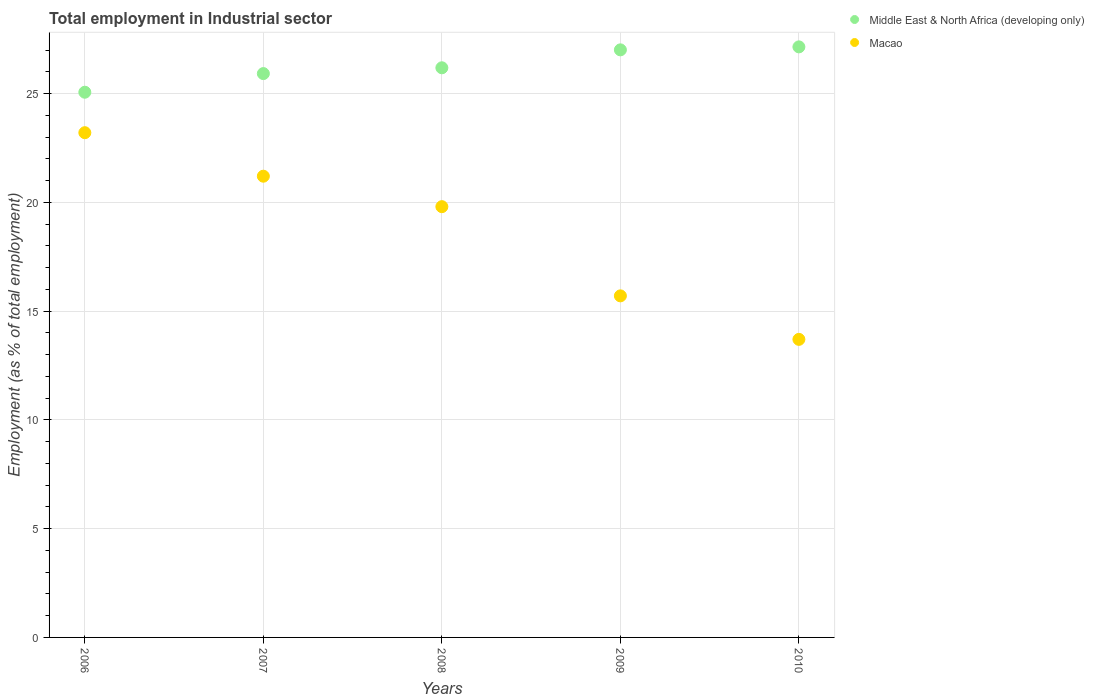How many different coloured dotlines are there?
Make the answer very short. 2. What is the employment in industrial sector in Middle East & North Africa (developing only) in 2009?
Provide a short and direct response. 27.01. Across all years, what is the maximum employment in industrial sector in Macao?
Give a very brief answer. 23.2. Across all years, what is the minimum employment in industrial sector in Macao?
Ensure brevity in your answer.  13.7. In which year was the employment in industrial sector in Middle East & North Africa (developing only) maximum?
Offer a very short reply. 2010. In which year was the employment in industrial sector in Macao minimum?
Ensure brevity in your answer.  2010. What is the total employment in industrial sector in Macao in the graph?
Your response must be concise. 93.6. What is the difference between the employment in industrial sector in Macao in 2006 and that in 2007?
Ensure brevity in your answer.  2. What is the difference between the employment in industrial sector in Middle East & North Africa (developing only) in 2009 and the employment in industrial sector in Macao in 2010?
Give a very brief answer. 13.31. What is the average employment in industrial sector in Middle East & North Africa (developing only) per year?
Your answer should be compact. 26.26. In the year 2009, what is the difference between the employment in industrial sector in Macao and employment in industrial sector in Middle East & North Africa (developing only)?
Give a very brief answer. -11.31. In how many years, is the employment in industrial sector in Middle East & North Africa (developing only) greater than 19 %?
Keep it short and to the point. 5. What is the ratio of the employment in industrial sector in Middle East & North Africa (developing only) in 2006 to that in 2007?
Your answer should be very brief. 0.97. Is the employment in industrial sector in Macao in 2008 less than that in 2010?
Give a very brief answer. No. Is the difference between the employment in industrial sector in Macao in 2007 and 2010 greater than the difference between the employment in industrial sector in Middle East & North Africa (developing only) in 2007 and 2010?
Offer a very short reply. Yes. What is the difference between the highest and the second highest employment in industrial sector in Middle East & North Africa (developing only)?
Your answer should be very brief. 0.14. What is the difference between the highest and the lowest employment in industrial sector in Macao?
Your response must be concise. 9.5. Is the employment in industrial sector in Macao strictly greater than the employment in industrial sector in Middle East & North Africa (developing only) over the years?
Your answer should be very brief. No. Is the employment in industrial sector in Middle East & North Africa (developing only) strictly less than the employment in industrial sector in Macao over the years?
Offer a very short reply. No. How many dotlines are there?
Keep it short and to the point. 2. How many years are there in the graph?
Your response must be concise. 5. Are the values on the major ticks of Y-axis written in scientific E-notation?
Provide a short and direct response. No. How many legend labels are there?
Offer a very short reply. 2. What is the title of the graph?
Your answer should be compact. Total employment in Industrial sector. What is the label or title of the Y-axis?
Make the answer very short. Employment (as % of total employment). What is the Employment (as % of total employment) of Middle East & North Africa (developing only) in 2006?
Provide a short and direct response. 25.06. What is the Employment (as % of total employment) of Macao in 2006?
Your answer should be very brief. 23.2. What is the Employment (as % of total employment) of Middle East & North Africa (developing only) in 2007?
Provide a succinct answer. 25.92. What is the Employment (as % of total employment) in Macao in 2007?
Ensure brevity in your answer.  21.2. What is the Employment (as % of total employment) in Middle East & North Africa (developing only) in 2008?
Give a very brief answer. 26.18. What is the Employment (as % of total employment) of Macao in 2008?
Your answer should be very brief. 19.8. What is the Employment (as % of total employment) in Middle East & North Africa (developing only) in 2009?
Give a very brief answer. 27.01. What is the Employment (as % of total employment) in Macao in 2009?
Offer a very short reply. 15.7. What is the Employment (as % of total employment) of Middle East & North Africa (developing only) in 2010?
Ensure brevity in your answer.  27.14. What is the Employment (as % of total employment) in Macao in 2010?
Your response must be concise. 13.7. Across all years, what is the maximum Employment (as % of total employment) in Middle East & North Africa (developing only)?
Your answer should be compact. 27.14. Across all years, what is the maximum Employment (as % of total employment) in Macao?
Give a very brief answer. 23.2. Across all years, what is the minimum Employment (as % of total employment) in Middle East & North Africa (developing only)?
Your answer should be very brief. 25.06. Across all years, what is the minimum Employment (as % of total employment) of Macao?
Your response must be concise. 13.7. What is the total Employment (as % of total employment) in Middle East & North Africa (developing only) in the graph?
Provide a succinct answer. 131.31. What is the total Employment (as % of total employment) of Macao in the graph?
Your answer should be compact. 93.6. What is the difference between the Employment (as % of total employment) of Middle East & North Africa (developing only) in 2006 and that in 2007?
Offer a very short reply. -0.86. What is the difference between the Employment (as % of total employment) of Macao in 2006 and that in 2007?
Make the answer very short. 2. What is the difference between the Employment (as % of total employment) in Middle East & North Africa (developing only) in 2006 and that in 2008?
Make the answer very short. -1.12. What is the difference between the Employment (as % of total employment) of Macao in 2006 and that in 2008?
Your answer should be very brief. 3.4. What is the difference between the Employment (as % of total employment) in Middle East & North Africa (developing only) in 2006 and that in 2009?
Your answer should be very brief. -1.95. What is the difference between the Employment (as % of total employment) in Macao in 2006 and that in 2009?
Keep it short and to the point. 7.5. What is the difference between the Employment (as % of total employment) of Middle East & North Africa (developing only) in 2006 and that in 2010?
Ensure brevity in your answer.  -2.08. What is the difference between the Employment (as % of total employment) of Middle East & North Africa (developing only) in 2007 and that in 2008?
Provide a succinct answer. -0.27. What is the difference between the Employment (as % of total employment) in Macao in 2007 and that in 2008?
Keep it short and to the point. 1.4. What is the difference between the Employment (as % of total employment) in Middle East & North Africa (developing only) in 2007 and that in 2009?
Make the answer very short. -1.09. What is the difference between the Employment (as % of total employment) of Macao in 2007 and that in 2009?
Give a very brief answer. 5.5. What is the difference between the Employment (as % of total employment) in Middle East & North Africa (developing only) in 2007 and that in 2010?
Your answer should be very brief. -1.23. What is the difference between the Employment (as % of total employment) in Middle East & North Africa (developing only) in 2008 and that in 2009?
Give a very brief answer. -0.82. What is the difference between the Employment (as % of total employment) of Macao in 2008 and that in 2009?
Offer a very short reply. 4.1. What is the difference between the Employment (as % of total employment) in Middle East & North Africa (developing only) in 2008 and that in 2010?
Offer a very short reply. -0.96. What is the difference between the Employment (as % of total employment) in Middle East & North Africa (developing only) in 2009 and that in 2010?
Your response must be concise. -0.14. What is the difference between the Employment (as % of total employment) of Macao in 2009 and that in 2010?
Provide a short and direct response. 2. What is the difference between the Employment (as % of total employment) of Middle East & North Africa (developing only) in 2006 and the Employment (as % of total employment) of Macao in 2007?
Give a very brief answer. 3.86. What is the difference between the Employment (as % of total employment) in Middle East & North Africa (developing only) in 2006 and the Employment (as % of total employment) in Macao in 2008?
Give a very brief answer. 5.26. What is the difference between the Employment (as % of total employment) of Middle East & North Africa (developing only) in 2006 and the Employment (as % of total employment) of Macao in 2009?
Make the answer very short. 9.36. What is the difference between the Employment (as % of total employment) in Middle East & North Africa (developing only) in 2006 and the Employment (as % of total employment) in Macao in 2010?
Offer a terse response. 11.36. What is the difference between the Employment (as % of total employment) in Middle East & North Africa (developing only) in 2007 and the Employment (as % of total employment) in Macao in 2008?
Offer a terse response. 6.12. What is the difference between the Employment (as % of total employment) in Middle East & North Africa (developing only) in 2007 and the Employment (as % of total employment) in Macao in 2009?
Your response must be concise. 10.22. What is the difference between the Employment (as % of total employment) of Middle East & North Africa (developing only) in 2007 and the Employment (as % of total employment) of Macao in 2010?
Give a very brief answer. 12.22. What is the difference between the Employment (as % of total employment) in Middle East & North Africa (developing only) in 2008 and the Employment (as % of total employment) in Macao in 2009?
Provide a short and direct response. 10.48. What is the difference between the Employment (as % of total employment) of Middle East & North Africa (developing only) in 2008 and the Employment (as % of total employment) of Macao in 2010?
Your answer should be compact. 12.48. What is the difference between the Employment (as % of total employment) in Middle East & North Africa (developing only) in 2009 and the Employment (as % of total employment) in Macao in 2010?
Offer a very short reply. 13.31. What is the average Employment (as % of total employment) of Middle East & North Africa (developing only) per year?
Provide a succinct answer. 26.26. What is the average Employment (as % of total employment) in Macao per year?
Your response must be concise. 18.72. In the year 2006, what is the difference between the Employment (as % of total employment) in Middle East & North Africa (developing only) and Employment (as % of total employment) in Macao?
Offer a terse response. 1.86. In the year 2007, what is the difference between the Employment (as % of total employment) of Middle East & North Africa (developing only) and Employment (as % of total employment) of Macao?
Your answer should be very brief. 4.72. In the year 2008, what is the difference between the Employment (as % of total employment) of Middle East & North Africa (developing only) and Employment (as % of total employment) of Macao?
Provide a short and direct response. 6.38. In the year 2009, what is the difference between the Employment (as % of total employment) in Middle East & North Africa (developing only) and Employment (as % of total employment) in Macao?
Ensure brevity in your answer.  11.31. In the year 2010, what is the difference between the Employment (as % of total employment) of Middle East & North Africa (developing only) and Employment (as % of total employment) of Macao?
Give a very brief answer. 13.44. What is the ratio of the Employment (as % of total employment) of Middle East & North Africa (developing only) in 2006 to that in 2007?
Offer a terse response. 0.97. What is the ratio of the Employment (as % of total employment) of Macao in 2006 to that in 2007?
Provide a short and direct response. 1.09. What is the ratio of the Employment (as % of total employment) of Middle East & North Africa (developing only) in 2006 to that in 2008?
Provide a short and direct response. 0.96. What is the ratio of the Employment (as % of total employment) of Macao in 2006 to that in 2008?
Your answer should be very brief. 1.17. What is the ratio of the Employment (as % of total employment) in Middle East & North Africa (developing only) in 2006 to that in 2009?
Offer a very short reply. 0.93. What is the ratio of the Employment (as % of total employment) in Macao in 2006 to that in 2009?
Make the answer very short. 1.48. What is the ratio of the Employment (as % of total employment) in Middle East & North Africa (developing only) in 2006 to that in 2010?
Your response must be concise. 0.92. What is the ratio of the Employment (as % of total employment) in Macao in 2006 to that in 2010?
Offer a very short reply. 1.69. What is the ratio of the Employment (as % of total employment) of Middle East & North Africa (developing only) in 2007 to that in 2008?
Your answer should be very brief. 0.99. What is the ratio of the Employment (as % of total employment) in Macao in 2007 to that in 2008?
Your response must be concise. 1.07. What is the ratio of the Employment (as % of total employment) in Middle East & North Africa (developing only) in 2007 to that in 2009?
Provide a short and direct response. 0.96. What is the ratio of the Employment (as % of total employment) of Macao in 2007 to that in 2009?
Offer a terse response. 1.35. What is the ratio of the Employment (as % of total employment) in Middle East & North Africa (developing only) in 2007 to that in 2010?
Make the answer very short. 0.95. What is the ratio of the Employment (as % of total employment) of Macao in 2007 to that in 2010?
Your answer should be very brief. 1.55. What is the ratio of the Employment (as % of total employment) of Middle East & North Africa (developing only) in 2008 to that in 2009?
Provide a short and direct response. 0.97. What is the ratio of the Employment (as % of total employment) in Macao in 2008 to that in 2009?
Give a very brief answer. 1.26. What is the ratio of the Employment (as % of total employment) of Middle East & North Africa (developing only) in 2008 to that in 2010?
Your answer should be very brief. 0.96. What is the ratio of the Employment (as % of total employment) in Macao in 2008 to that in 2010?
Give a very brief answer. 1.45. What is the ratio of the Employment (as % of total employment) in Middle East & North Africa (developing only) in 2009 to that in 2010?
Your response must be concise. 0.99. What is the ratio of the Employment (as % of total employment) in Macao in 2009 to that in 2010?
Your answer should be very brief. 1.15. What is the difference between the highest and the second highest Employment (as % of total employment) of Middle East & North Africa (developing only)?
Your answer should be very brief. 0.14. What is the difference between the highest and the second highest Employment (as % of total employment) in Macao?
Your answer should be very brief. 2. What is the difference between the highest and the lowest Employment (as % of total employment) in Middle East & North Africa (developing only)?
Make the answer very short. 2.08. What is the difference between the highest and the lowest Employment (as % of total employment) of Macao?
Your answer should be compact. 9.5. 